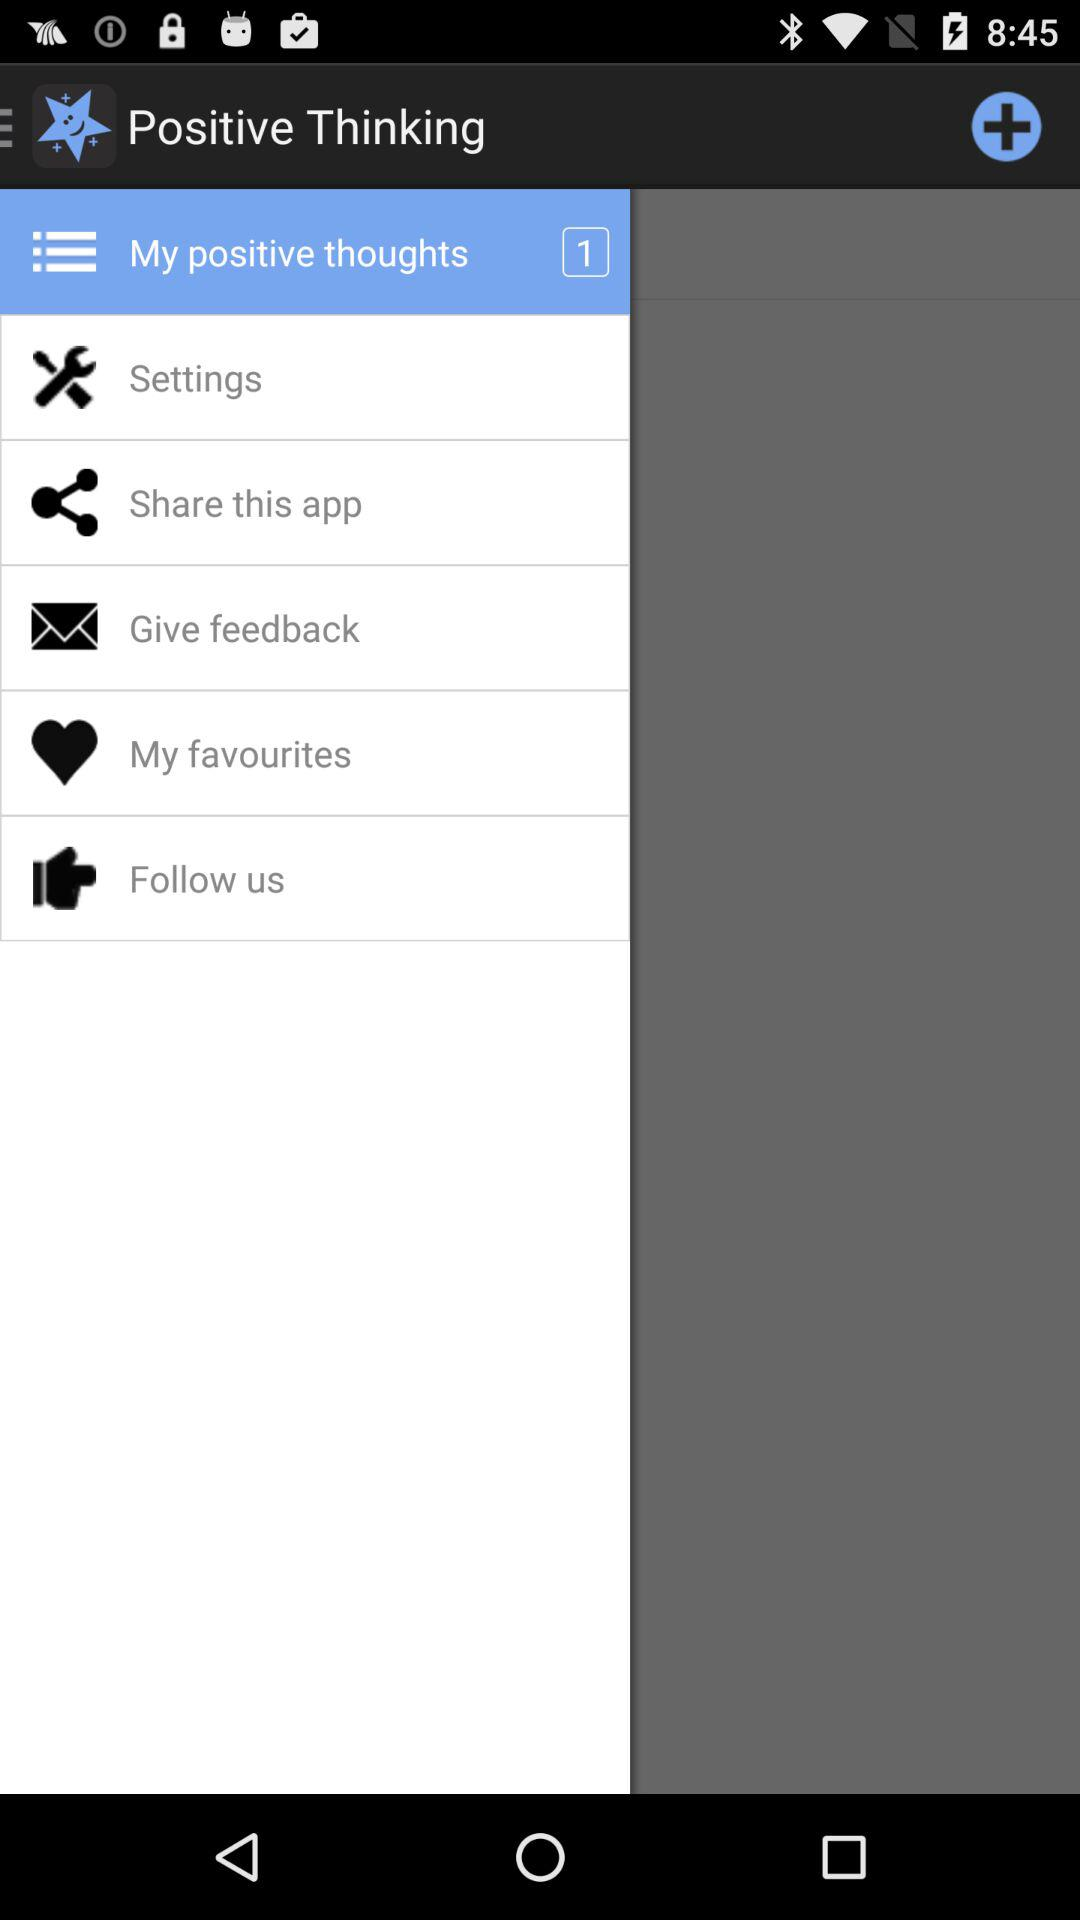What is the application name? The application name is "Positive Thinking". 